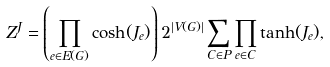<formula> <loc_0><loc_0><loc_500><loc_500>Z ^ { J } = \left ( \prod _ { e \in E ( G ) } \cosh ( J _ { e } ) \right ) 2 ^ { | V ( G ) | } \sum _ { C \in P } \prod _ { e \in C } \tanh ( J _ { e } ) ,</formula> 